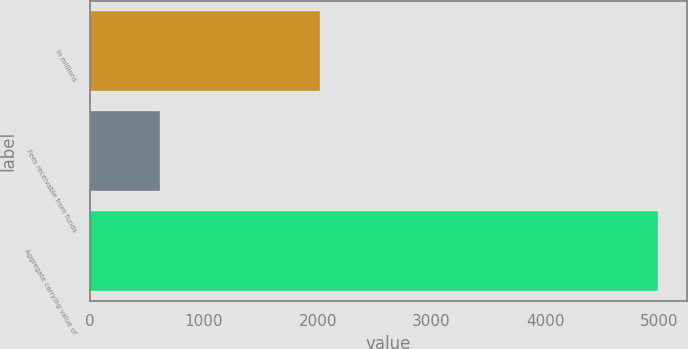<chart> <loc_0><loc_0><loc_500><loc_500><bar_chart><fcel>in millions<fcel>Fees receivable from funds<fcel>Aggregate carrying value of<nl><fcel>2018<fcel>610<fcel>4994<nl></chart> 